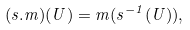Convert formula to latex. <formula><loc_0><loc_0><loc_500><loc_500>( s . m ) ( U ) = m ( s ^ { - 1 } ( U ) ) ,</formula> 